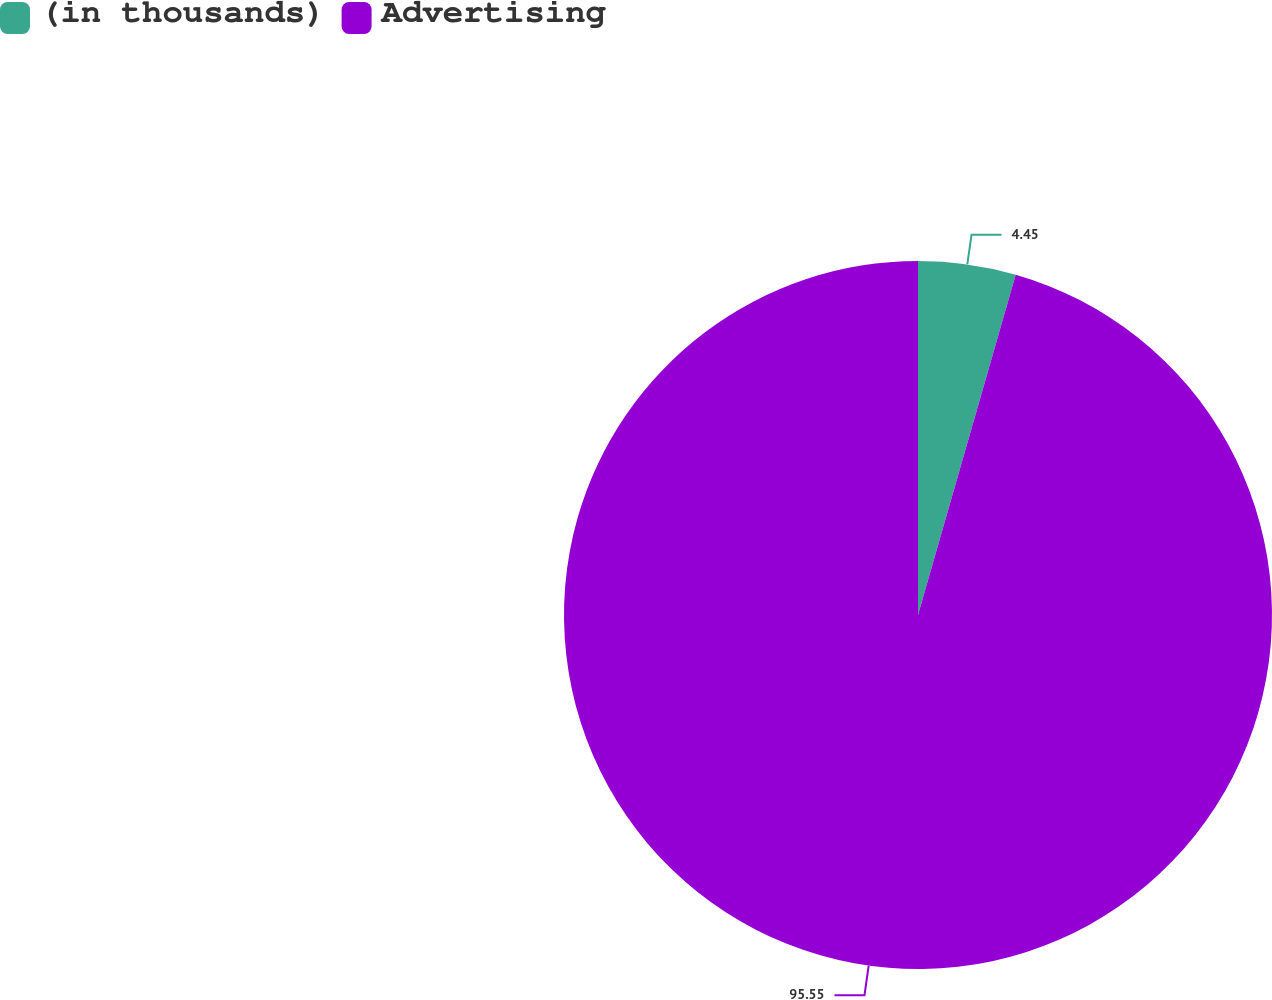<chart> <loc_0><loc_0><loc_500><loc_500><pie_chart><fcel>(in thousands)<fcel>Advertising<nl><fcel>4.45%<fcel>95.55%<nl></chart> 